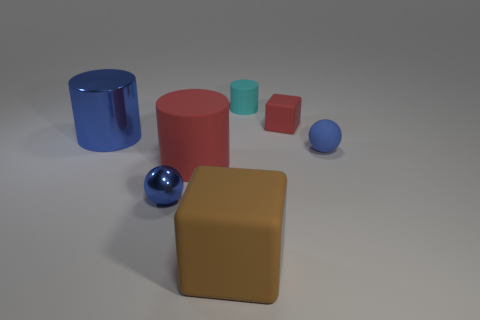Can you speculate on the materials the objects are made of based on their appearance? Certainly! The blue cylinder and blue sphere exhibit reflective qualities that suggest they are made of a polished metal, possibly steel or aluminum. The red cylinder, the tan cube, and the smaller light blue cylinder, on the other hand, have matte finishes which could imply a plastic or painted wooden material. The small orange cube also appears matte and is likely made of a similar material as the red cylinder and tan cube. Overall, the scene likely contains a mix of metallic and non-metallic items. 